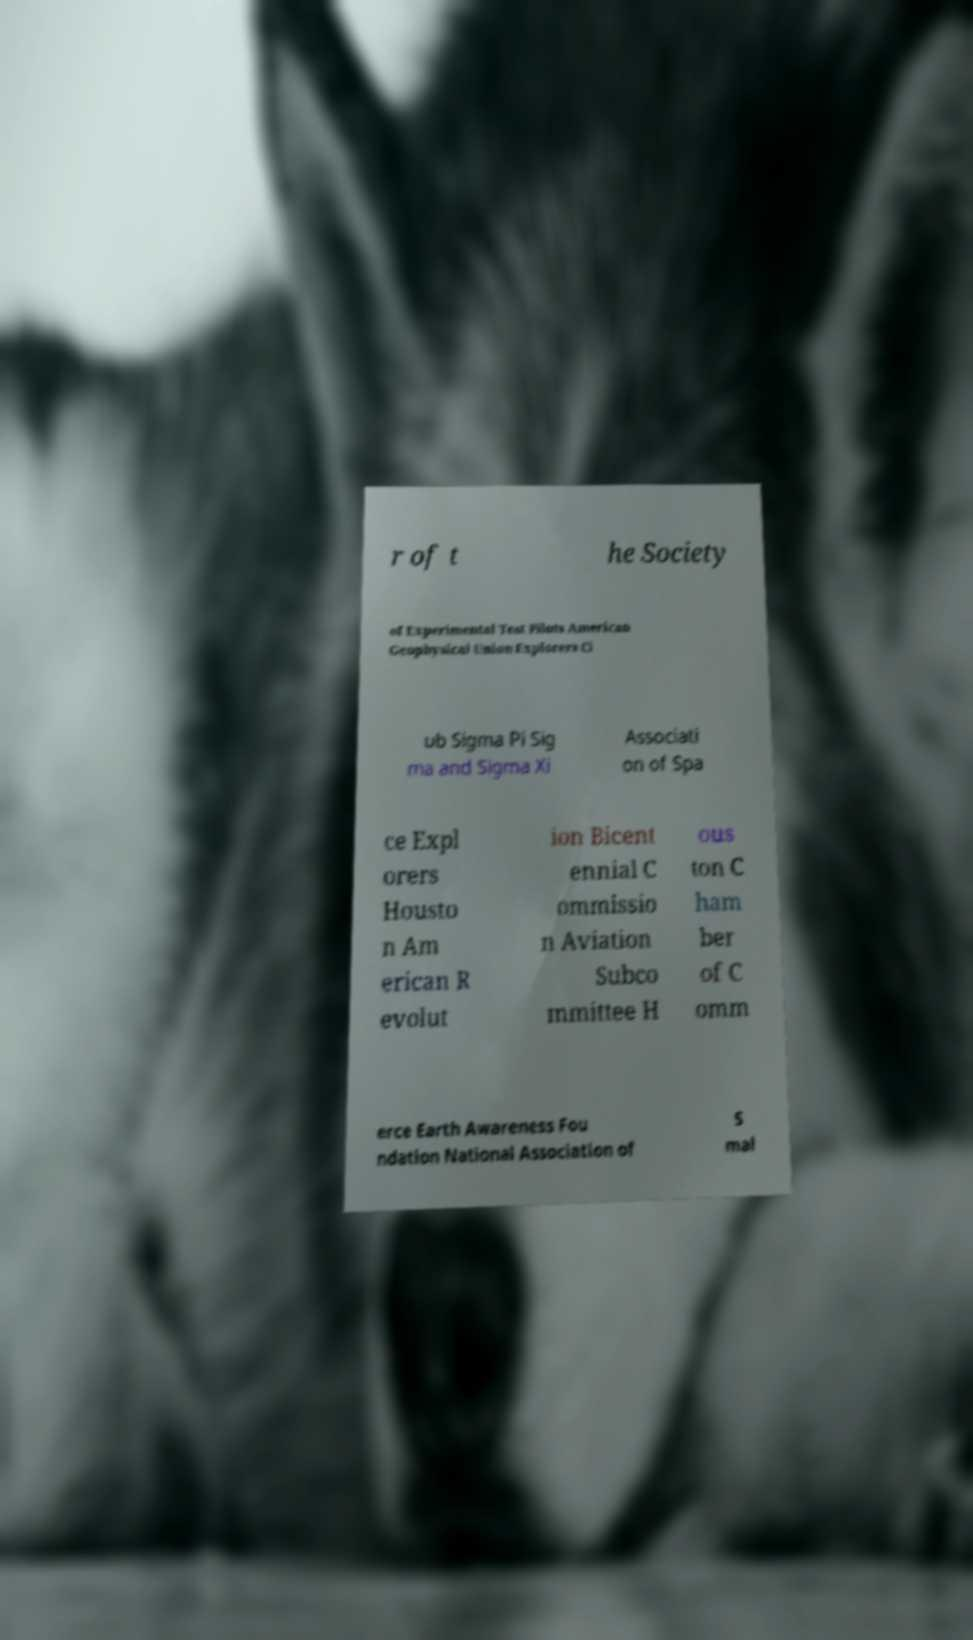Can you accurately transcribe the text from the provided image for me? r of t he Society of Experimental Test Pilots American Geophysical Union Explorers Cl ub Sigma Pi Sig ma and Sigma Xi Associati on of Spa ce Expl orers Housto n Am erican R evolut ion Bicent ennial C ommissio n Aviation Subco mmittee H ous ton C ham ber of C omm erce Earth Awareness Fou ndation National Association of S mal 